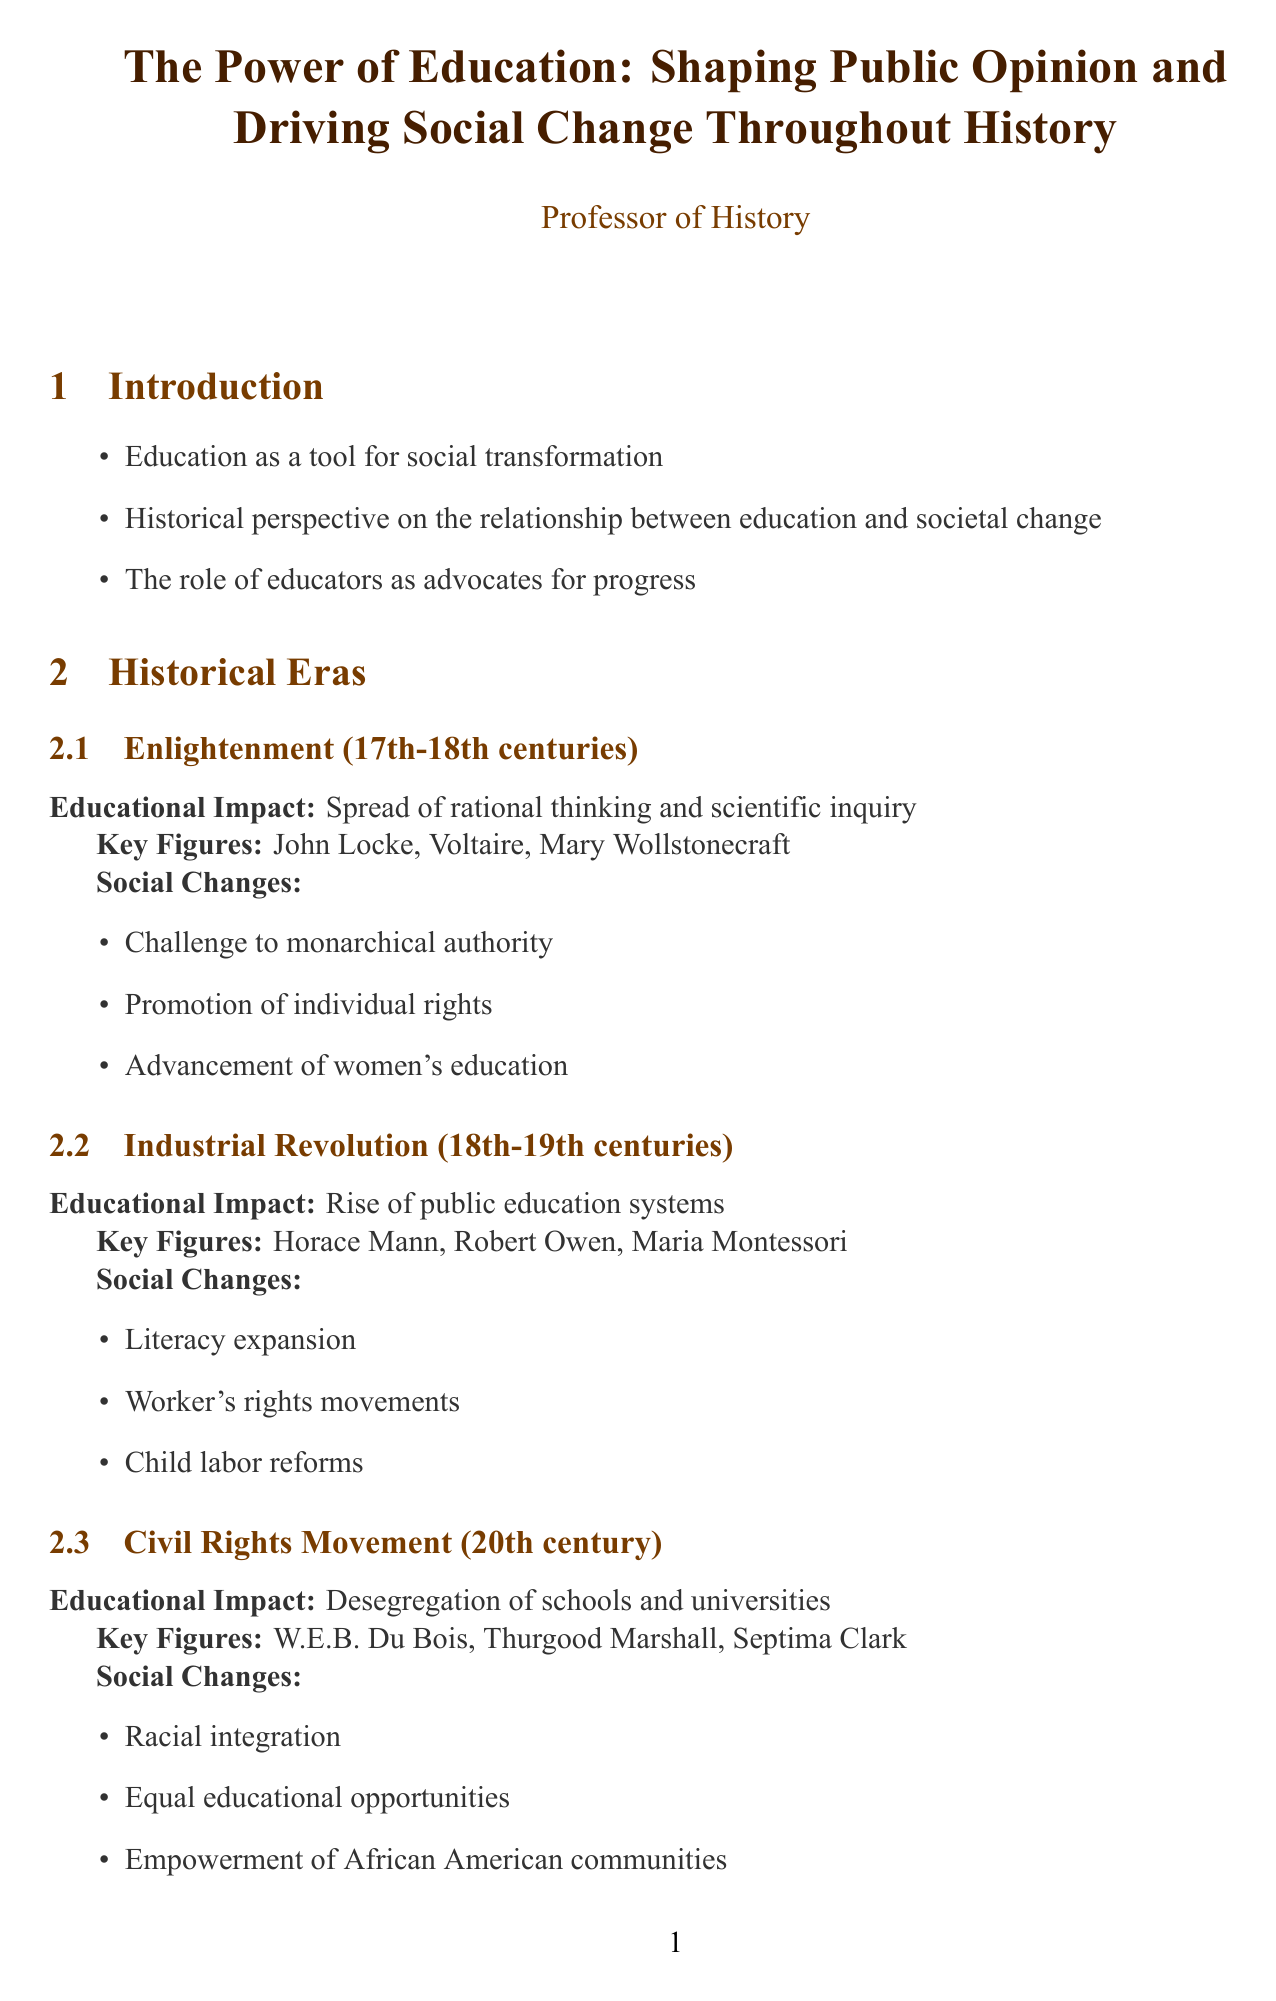What is the report's title? The title is mentioned at the beginning of the document, providing the main focus of the report.
Answer: The Power of Education: Shaping Public Opinion and Driving Social Change Throughout History Who are three key figures from the Enlightenment era? Key figures are listed under the Historical Eras section, specifically for the Enlightenment era.
Answer: John Locke, Voltaire, Mary Wollstonecraft What significant social change occurred during the Civil Rights Movement? The document outlines major social changes for each historical era, specifying those from the Civil Rights Movement.
Answer: Racial integration What educational impact is associated with the Industrial Revolution? The report identifies the educational impacts for various historical eras, including the Industrial Revolution.
Answer: Rise of public education systems What was John Dewey's educational philosophy? The case study about Dewey provides insights into his views on education, highlighting his contributions.
Answer: Experiential learning Which contemporary topic is mentioned regarding raising awareness? The contemporary examples section discusses various modern initiatives related to social issues, including their focus areas.
Answer: Climate Change Education What type of resource is "Waiting for 'Superman'"? The Additional Resources section classifies various materials, specifying what type of resource each item is.
Answer: Documentary What is a key conclusion drawn in the report? The conclusion points summarize the main ideas, showing the document's overall themes and takeaways.
Answer: Education as a catalyst for social change throughout history 